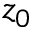Convert formula to latex. <formula><loc_0><loc_0><loc_500><loc_500>z _ { 0 }</formula> 